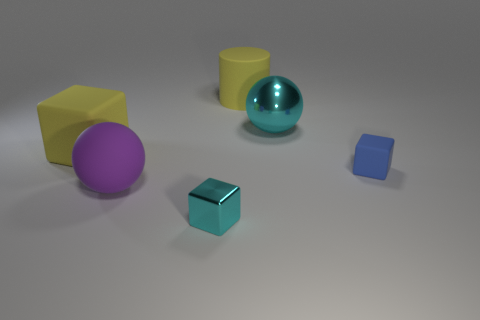There is a block in front of the purple thing; is its color the same as the ball that is behind the purple ball?
Give a very brief answer. Yes. What number of shiny things are there?
Offer a very short reply. 2. Are there any tiny blocks behind the purple thing?
Offer a terse response. Yes. Is the material of the object that is in front of the purple rubber sphere the same as the cube behind the small blue thing?
Your response must be concise. No. Are there fewer big objects on the right side of the big purple rubber sphere than purple matte blocks?
Offer a very short reply. No. There is a small thing that is in front of the large purple rubber object; what is its color?
Your answer should be compact. Cyan. There is a tiny thing right of the yellow object right of the yellow cube; what is it made of?
Offer a very short reply. Rubber. Is there a purple ball that has the same size as the cyan block?
Offer a very short reply. No. What number of things are rubber cubes left of the large yellow rubber cylinder or big matte objects that are on the left side of the large purple sphere?
Your answer should be compact. 1. There is a rubber object right of the large metallic object; does it have the same size as the block in front of the small rubber block?
Offer a very short reply. Yes. 